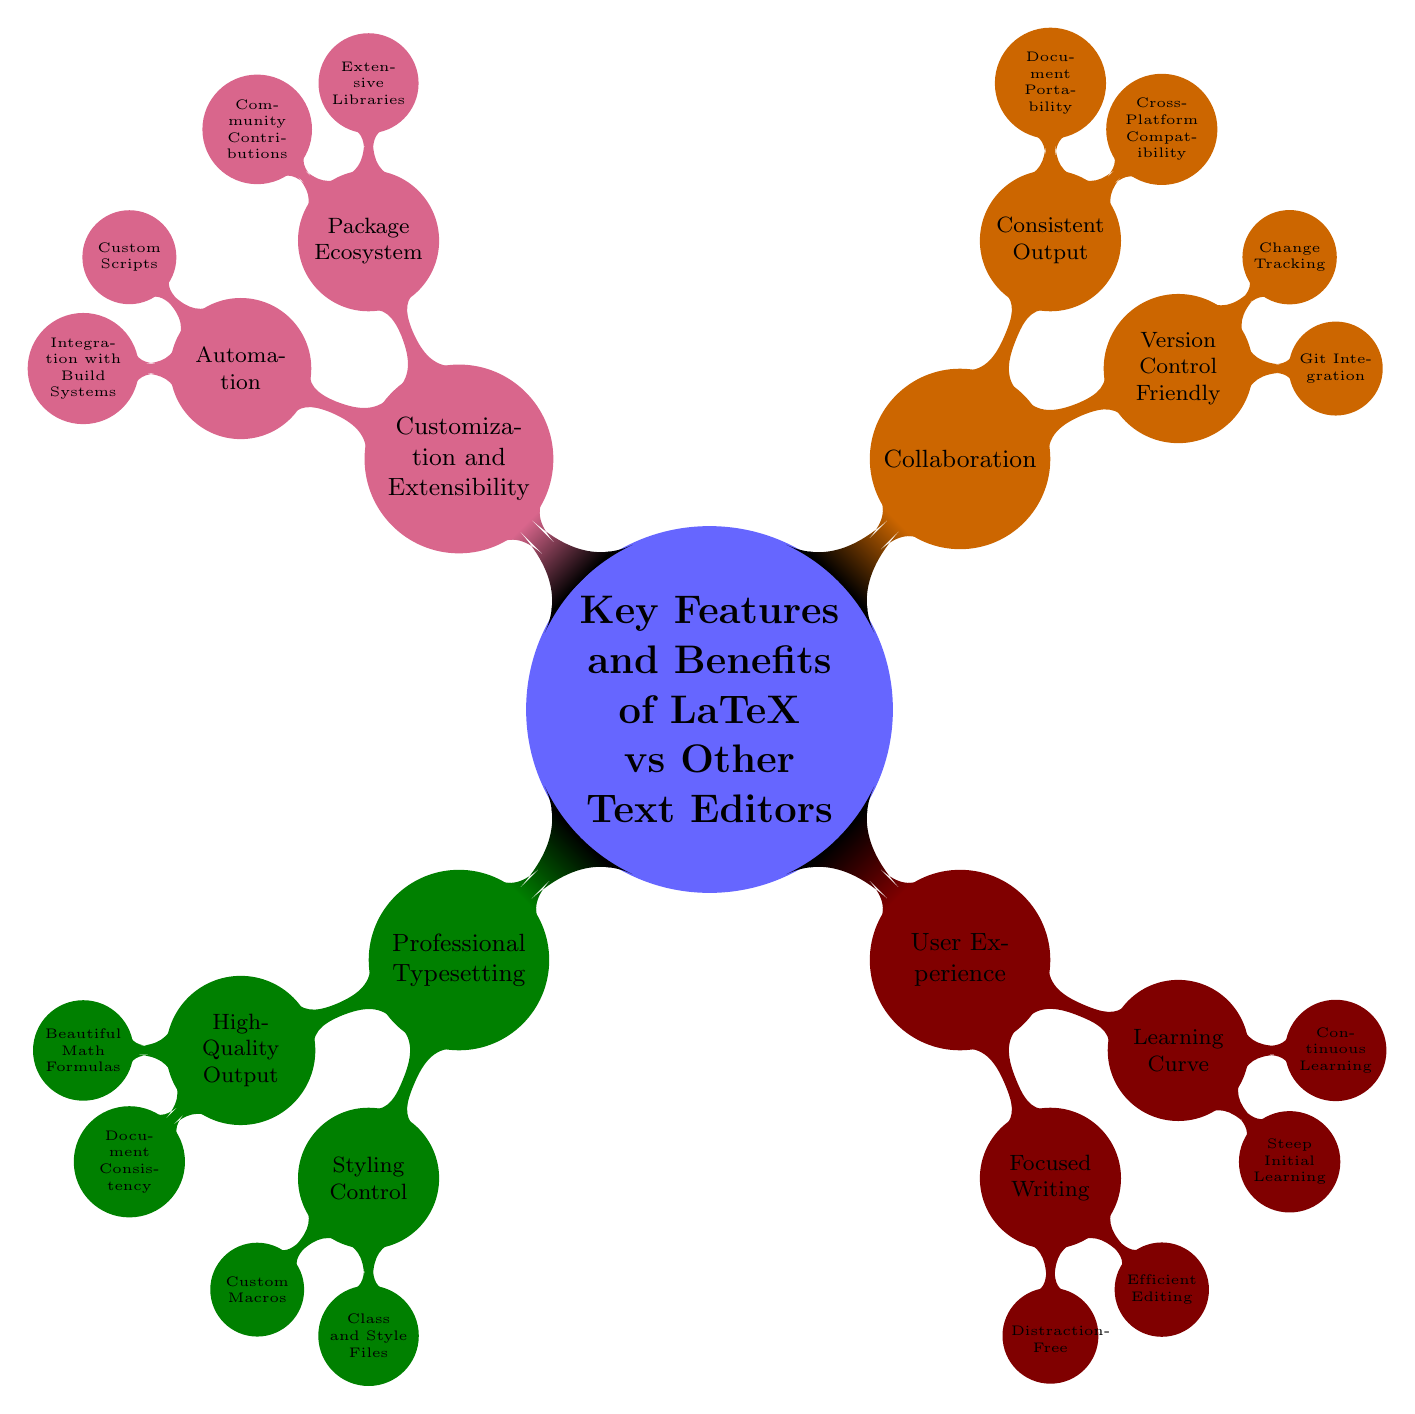What is the central topic of the mind map? The central topic node clearly displays the theme of the diagram, which is focused on comparing LaTeX with other text editors.
Answer: Key Features and Benefits of LaTeX versus Other Text Editors How many branches are directly connected to the central topic? By analyzing the diagram's main connections, I identify that four main branches stem from the central topic.
Answer: 4 What is one example of a document type that LaTeX produces high-quality output for? Scanning through the node for "High-Quality Output," I see that "Beautiful Math Formulas" lists Mathematics and Physics Papers as examples.
Answer: Mathematics, Physics Papers Which feature allows for distraction-free writing in LaTeX? Looking under the "Focused Writing" branch, the "Distraction-Free" node indicates that it refers to a minimal interface.
Answer: Distraction-Free What type of files provide styling control in LaTeX? Under the "Styling Control" branch, the "Class and Style Files" node provides the examples of the types of files available, including IEEEtran and beamer.
Answer: Class and Style Files What aspect of collaboration does LaTeX support through Git? In the "Collaboration" section, specifically under "Version Control Friendly," the node "Git Integration" illustrates that LaTeX supports collaboration through version control.
Answer: Git Integration What is one example of an extensive library available in LaTeX? Under the "Package Ecosystem," the "Extensive Libraries" node lists BibTeX as an example of a library that users can utilize in LaTeX.
Answer: BibTeX How does LaTeX ensure consistent output across different operating systems? The "Consistent Output" branch has a node titled "Cross-Platform Compatibility," which conveys that LaTeX guarantees the same output on any operating system.
Answer: Cross-Platform Compatibility What is one way LaTeX users automate tasks? The "Automation" branch includes a node labeled "Custom Scripts," showing that users can automate repetitive tasks through scripting.
Answer: Custom Scripts 